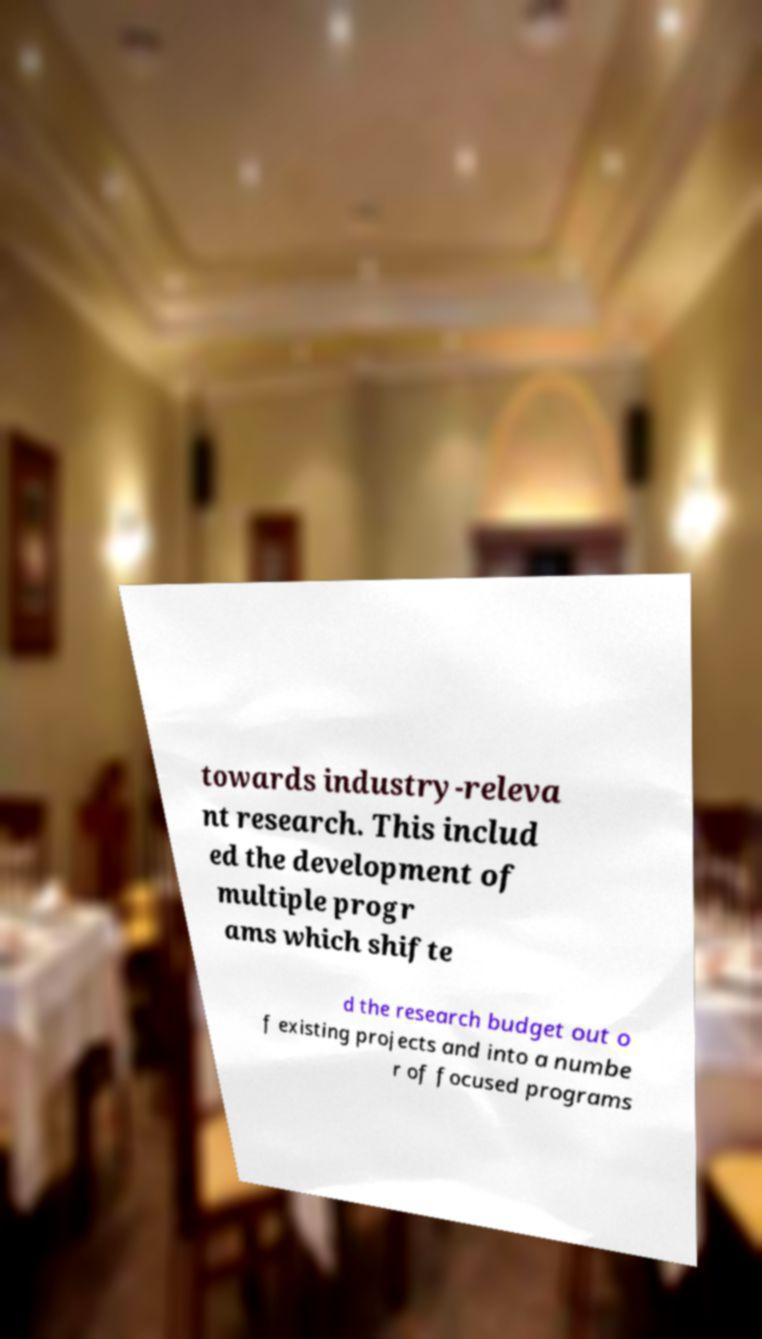Could you assist in decoding the text presented in this image and type it out clearly? towards industry-releva nt research. This includ ed the development of multiple progr ams which shifte d the research budget out o f existing projects and into a numbe r of focused programs 